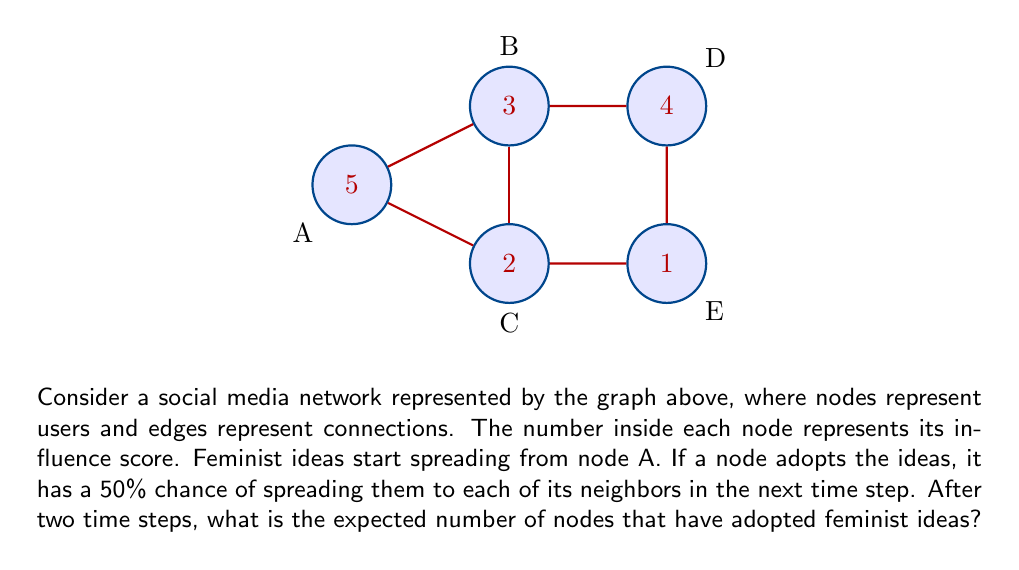Can you answer this question? Let's approach this step-by-step:

1) At time step 0, only node A has adopted the feminist ideas.

2) For the first time step:
   - Node A can spread to B and C, each with 50% probability.
   - Probability of B adopting: $P(B) = 0.5$
   - Probability of C adopting: $P(C) = 0.5$

3) For the second time step:
   - If B adopted in step 1, it can spread to D with 50% probability.
   - If C adopted in step 1, it can spread to E with 50% probability.
   - Probability of D adopting: $P(D) = P(B) \times 0.5 = 0.5 \times 0.5 = 0.25$
   - Probability of E adopting: $P(E) = P(C) \times 0.5 = 0.5 \times 0.5 = 0.25$

4) To calculate the expected number of nodes that have adopted after two time steps:
   - A is always included (1 node)
   - Expected number from B and C: $2 \times 0.5 = 1$ node
   - Expected number from D and E: $2 \times 0.25 = 0.5$ nodes

5) Total expected number: $1 + 1 + 0.5 = 2.5$ nodes

Therefore, after two time steps, the expected number of nodes that have adopted feminist ideas is 2.5.
Answer: 2.5 nodes 